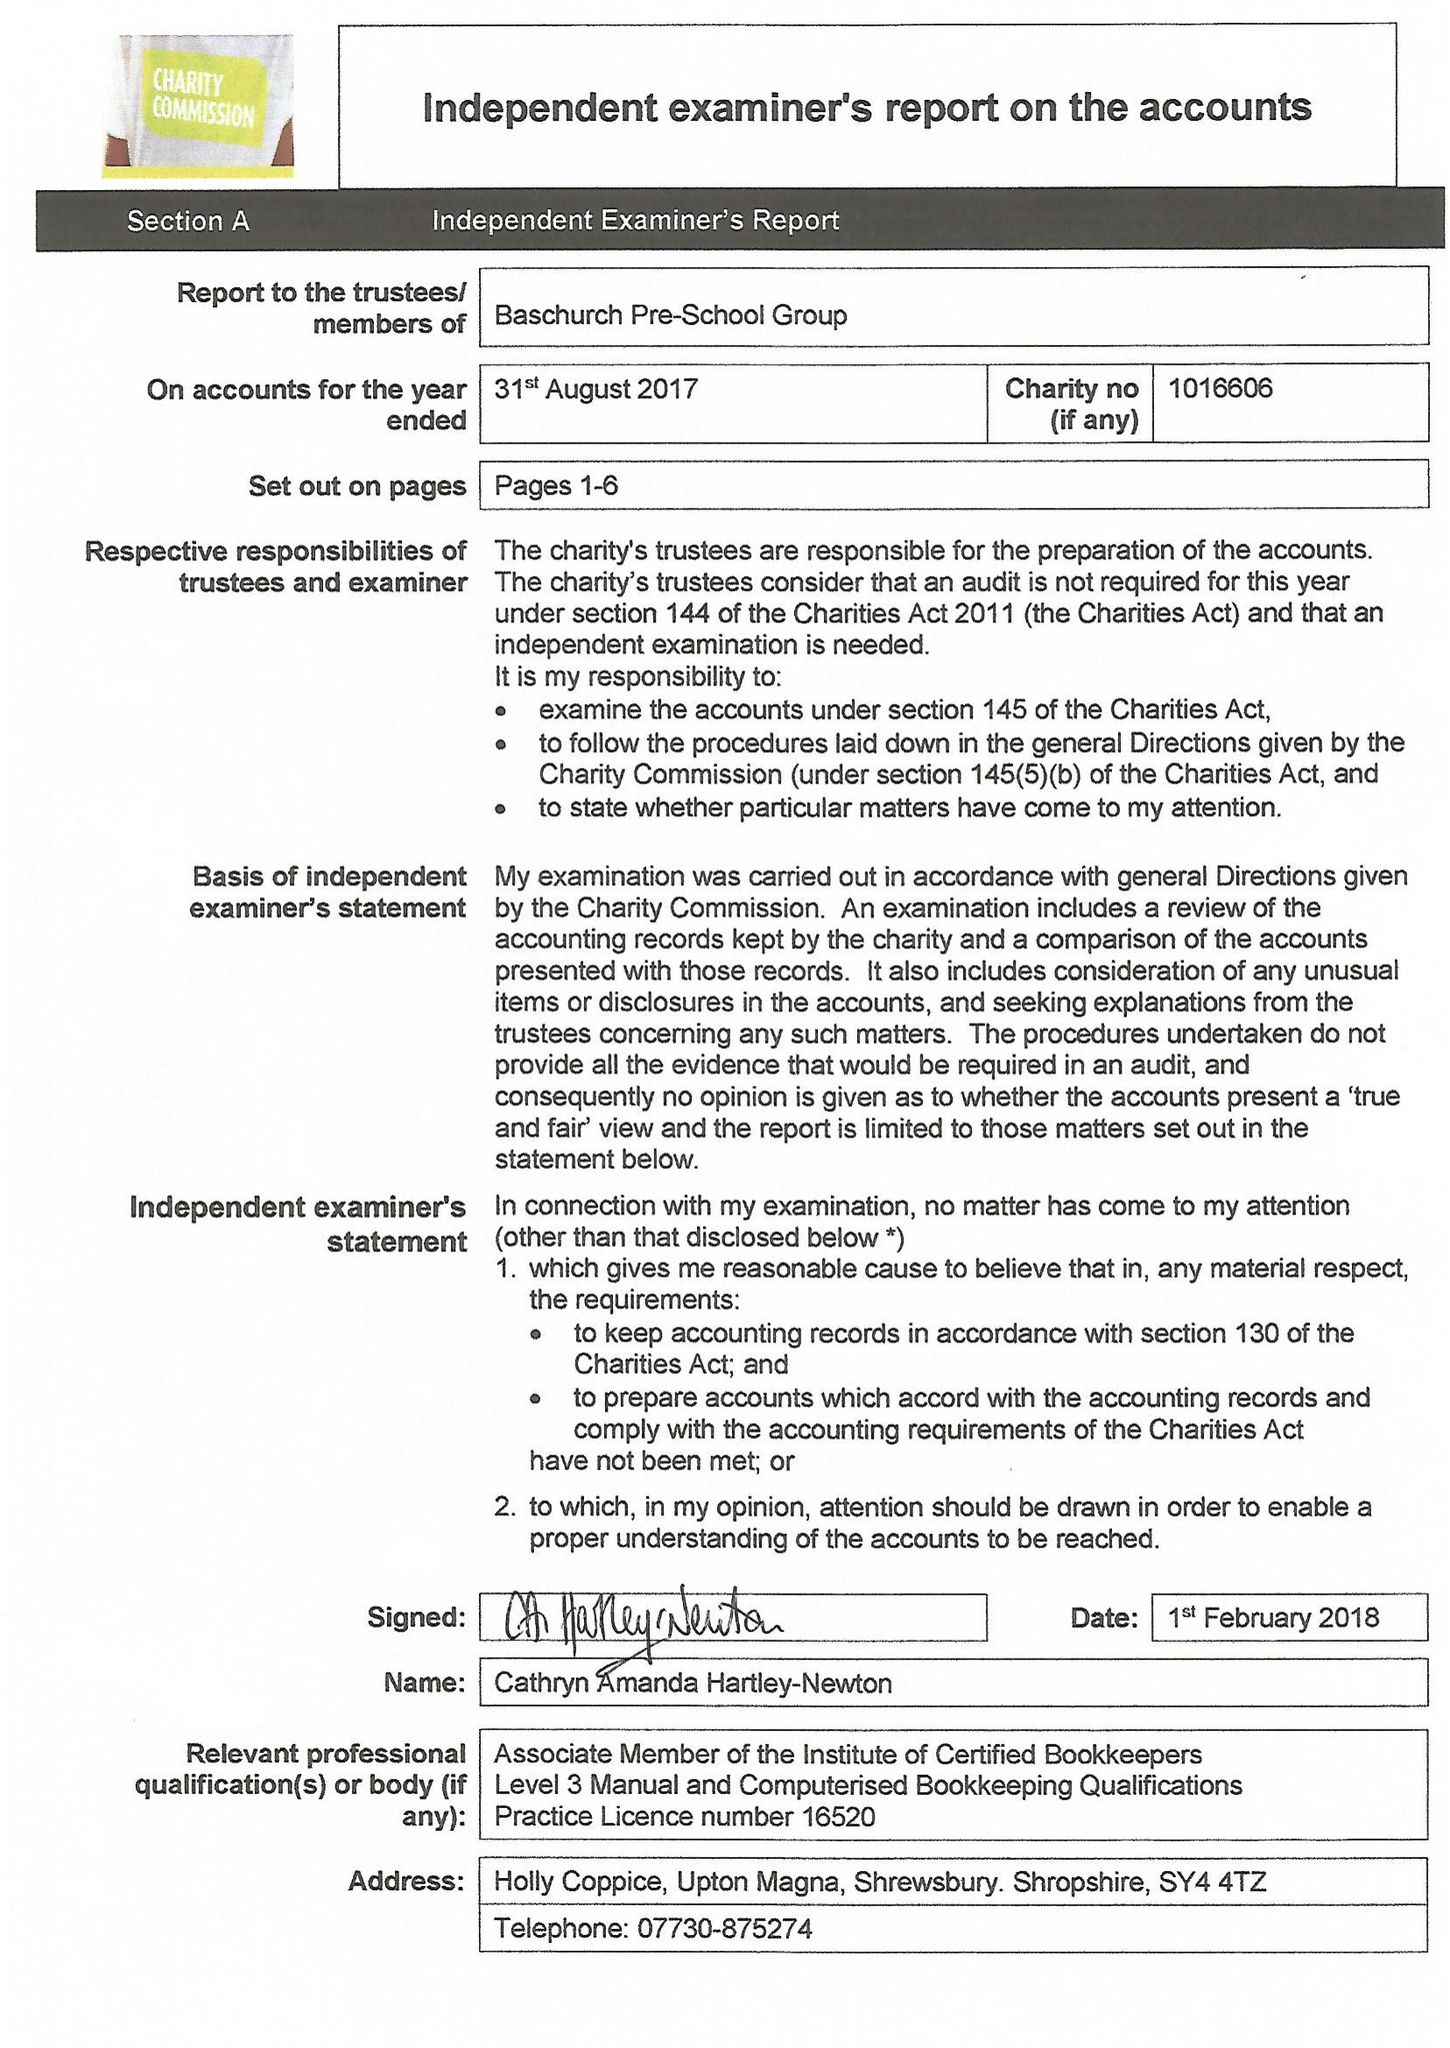What is the value for the charity_number?
Answer the question using a single word or phrase. 1016606 